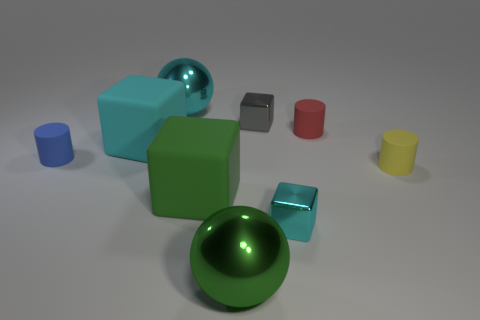Subtract 1 cubes. How many cubes are left? 3 Subtract all cubes. How many objects are left? 5 Add 6 big spheres. How many big spheres exist? 8 Subtract 1 green cubes. How many objects are left? 8 Subtract all small cyan shiny things. Subtract all metal objects. How many objects are left? 4 Add 4 green metal objects. How many green metal objects are left? 5 